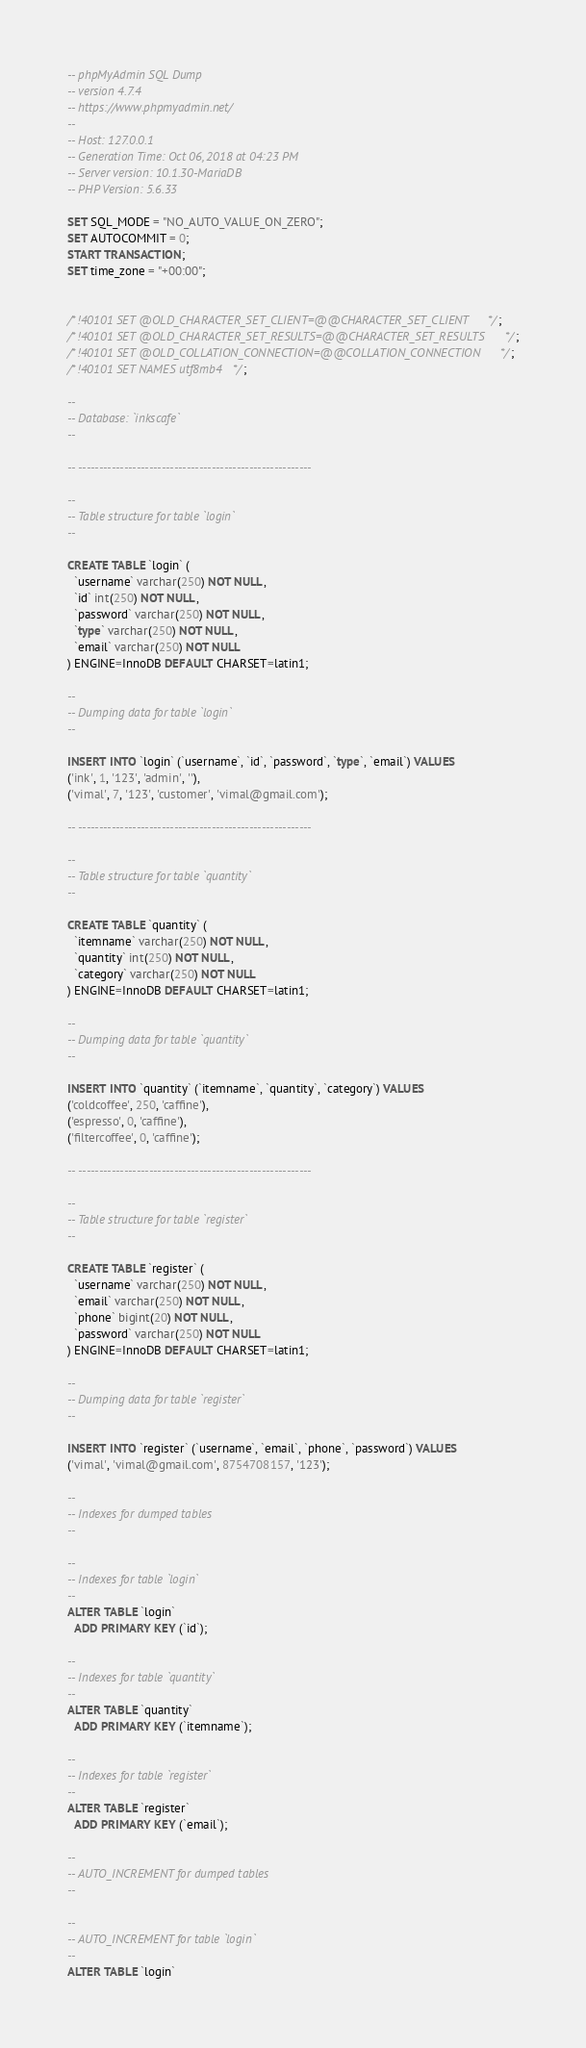<code> <loc_0><loc_0><loc_500><loc_500><_SQL_>-- phpMyAdmin SQL Dump
-- version 4.7.4
-- https://www.phpmyadmin.net/
--
-- Host: 127.0.0.1
-- Generation Time: Oct 06, 2018 at 04:23 PM
-- Server version: 10.1.30-MariaDB
-- PHP Version: 5.6.33

SET SQL_MODE = "NO_AUTO_VALUE_ON_ZERO";
SET AUTOCOMMIT = 0;
START TRANSACTION;
SET time_zone = "+00:00";


/*!40101 SET @OLD_CHARACTER_SET_CLIENT=@@CHARACTER_SET_CLIENT */;
/*!40101 SET @OLD_CHARACTER_SET_RESULTS=@@CHARACTER_SET_RESULTS */;
/*!40101 SET @OLD_COLLATION_CONNECTION=@@COLLATION_CONNECTION */;
/*!40101 SET NAMES utf8mb4 */;

--
-- Database: `inkscafe`
--

-- --------------------------------------------------------

--
-- Table structure for table `login`
--

CREATE TABLE `login` (
  `username` varchar(250) NOT NULL,
  `id` int(250) NOT NULL,
  `password` varchar(250) NOT NULL,
  `type` varchar(250) NOT NULL,
  `email` varchar(250) NOT NULL
) ENGINE=InnoDB DEFAULT CHARSET=latin1;

--
-- Dumping data for table `login`
--

INSERT INTO `login` (`username`, `id`, `password`, `type`, `email`) VALUES
('ink', 1, '123', 'admin', ''),
('vimal', 7, '123', 'customer', 'vimal@gmail.com');

-- --------------------------------------------------------

--
-- Table structure for table `quantity`
--

CREATE TABLE `quantity` (
  `itemname` varchar(250) NOT NULL,
  `quantity` int(250) NOT NULL,
  `category` varchar(250) NOT NULL
) ENGINE=InnoDB DEFAULT CHARSET=latin1;

--
-- Dumping data for table `quantity`
--

INSERT INTO `quantity` (`itemname`, `quantity`, `category`) VALUES
('coldcoffee', 250, 'caffine'),
('espresso', 0, 'caffine'),
('filtercoffee', 0, 'caffine');

-- --------------------------------------------------------

--
-- Table structure for table `register`
--

CREATE TABLE `register` (
  `username` varchar(250) NOT NULL,
  `email` varchar(250) NOT NULL,
  `phone` bigint(20) NOT NULL,
  `password` varchar(250) NOT NULL
) ENGINE=InnoDB DEFAULT CHARSET=latin1;

--
-- Dumping data for table `register`
--

INSERT INTO `register` (`username`, `email`, `phone`, `password`) VALUES
('vimal', 'vimal@gmail.com', 8754708157, '123');

--
-- Indexes for dumped tables
--

--
-- Indexes for table `login`
--
ALTER TABLE `login`
  ADD PRIMARY KEY (`id`);

--
-- Indexes for table `quantity`
--
ALTER TABLE `quantity`
  ADD PRIMARY KEY (`itemname`);

--
-- Indexes for table `register`
--
ALTER TABLE `register`
  ADD PRIMARY KEY (`email`);

--
-- AUTO_INCREMENT for dumped tables
--

--
-- AUTO_INCREMENT for table `login`
--
ALTER TABLE `login`</code> 